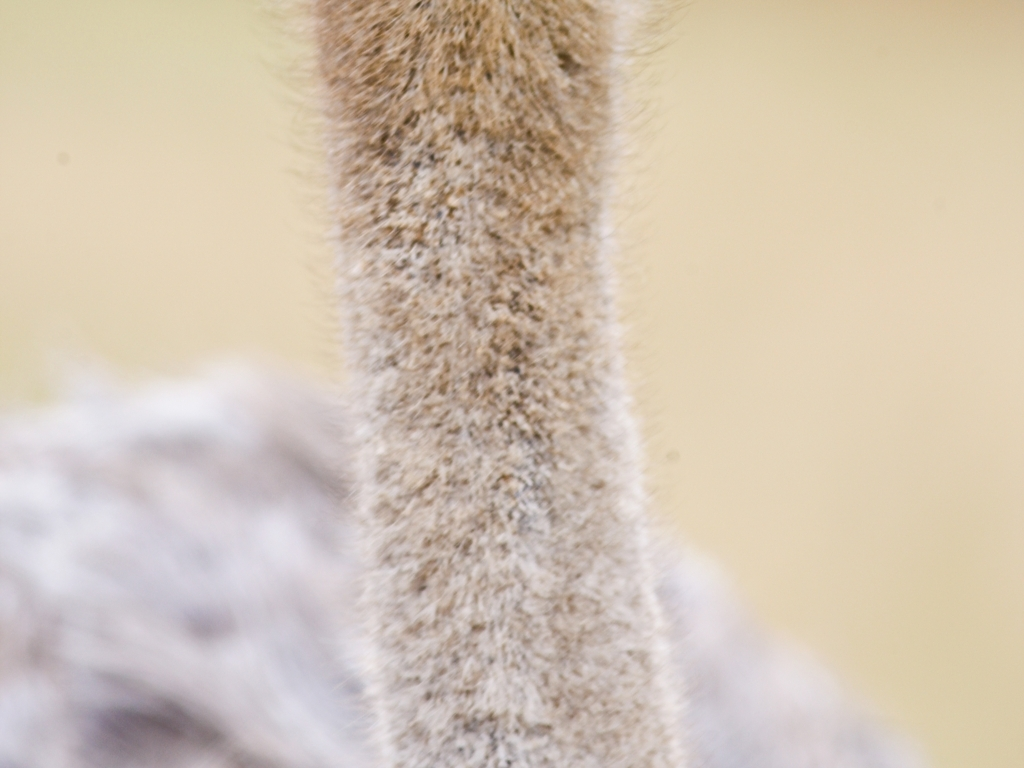How does the blurred quality of the image affect its potential use? The blurred quality of this image could be seen as a drawback for uses that require clear, detailed visual information, such as scientific documentation or identification. However, it might be valued in artistic contexts that favor ambiguity and texture over clarity. 